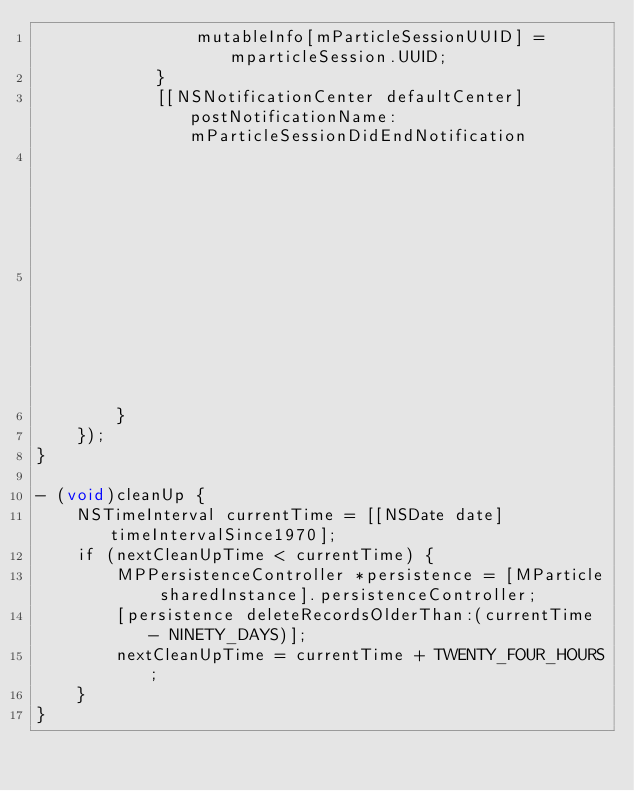<code> <loc_0><loc_0><loc_500><loc_500><_ObjectiveC_>                mutableInfo[mParticleSessionUUID] = mparticleSession.UUID;
            }
            [[NSNotificationCenter defaultCenter] postNotificationName:mParticleSessionDidEndNotification
                                                                object:strongSelf.delegate
                                                              userInfo:[mutableInfo copy]];
        }
    });
}

- (void)cleanUp {
    NSTimeInterval currentTime = [[NSDate date] timeIntervalSince1970];
    if (nextCleanUpTime < currentTime) {
        MPPersistenceController *persistence = [MParticle sharedInstance].persistenceController;
        [persistence deleteRecordsOlderThan:(currentTime - NINETY_DAYS)];
        nextCleanUpTime = currentTime + TWENTY_FOUR_HOURS;
    }
}
                   </code> 